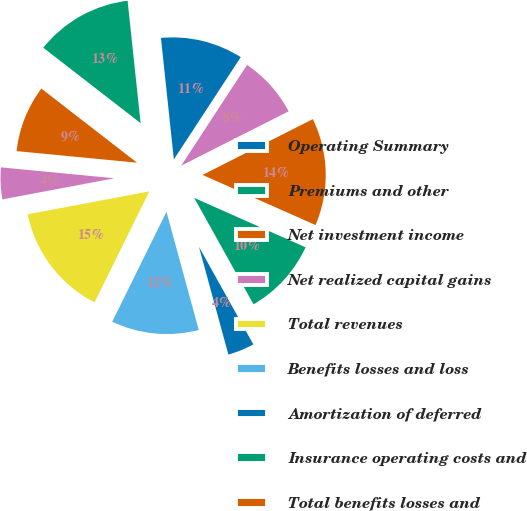Convert chart. <chart><loc_0><loc_0><loc_500><loc_500><pie_chart><fcel>Operating Summary<fcel>Premiums and other<fcel>Net investment income<fcel>Net realized capital gains<fcel>Total revenues<fcel>Benefits losses and loss<fcel>Amortization of deferred<fcel>Insurance operating costs and<fcel>Total benefits losses and<fcel>Income before income taxes<nl><fcel>10.9%<fcel>12.82%<fcel>8.97%<fcel>4.49%<fcel>14.74%<fcel>11.54%<fcel>3.85%<fcel>10.26%<fcel>14.1%<fcel>8.33%<nl></chart> 